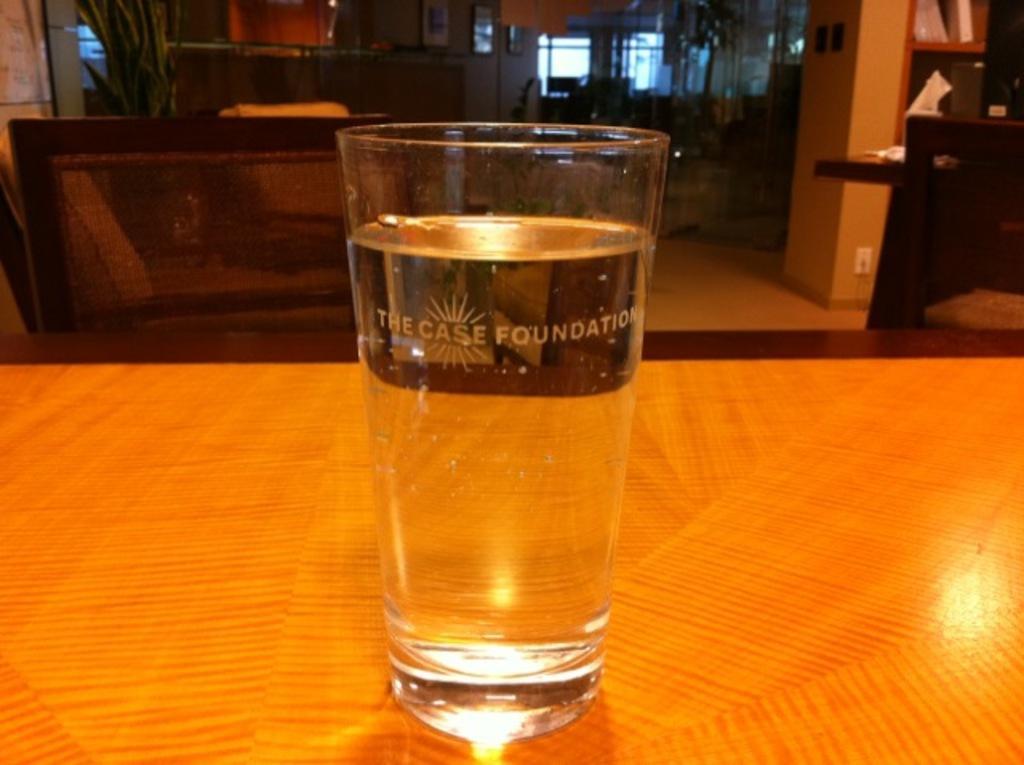Can you describe this image briefly? In the image we can see there is a glass of water on the table. 